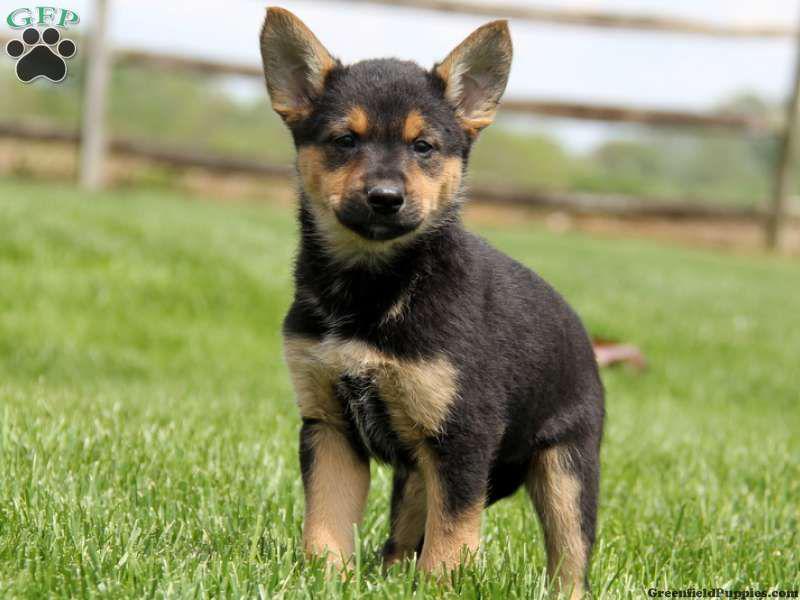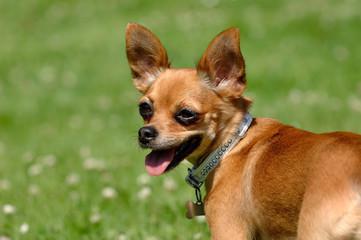The first image is the image on the left, the second image is the image on the right. Evaluate the accuracy of this statement regarding the images: "A dog in one image is photographed while in mid-air.". Is it true? Answer yes or no. No. 